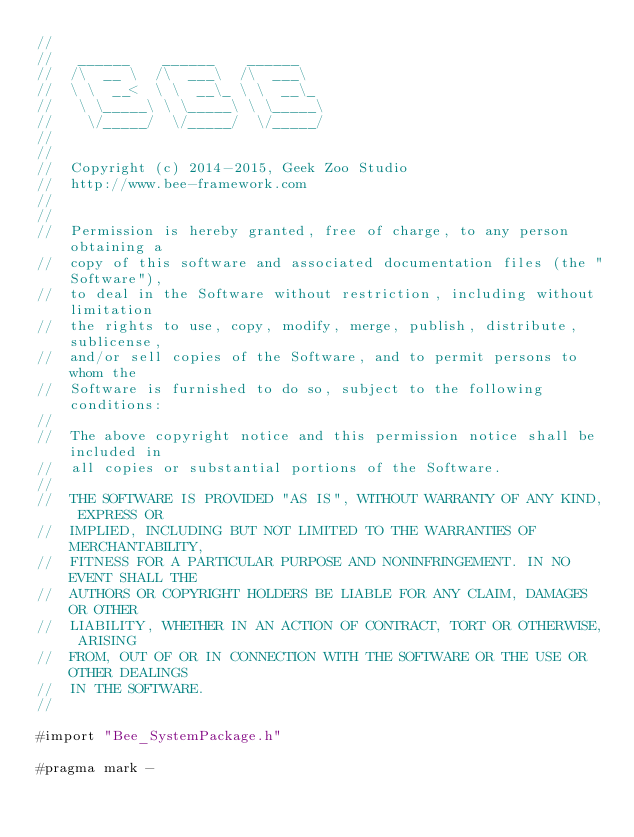<code> <loc_0><loc_0><loc_500><loc_500><_ObjectiveC_>//
//	 ______    ______    ______
//	/\  __ \  /\  ___\  /\  ___\
//	\ \  __<  \ \  __\_ \ \  __\_
//	 \ \_____\ \ \_____\ \ \_____\
//	  \/_____/  \/_____/  \/_____/
//
//
//	Copyright (c) 2014-2015, Geek Zoo Studio
//	http://www.bee-framework.com
//
//
//	Permission is hereby granted, free of charge, to any person obtaining a
//	copy of this software and associated documentation files (the "Software"),
//	to deal in the Software without restriction, including without limitation
//	the rights to use, copy, modify, merge, publish, distribute, sublicense,
//	and/or sell copies of the Software, and to permit persons to whom the
//	Software is furnished to do so, subject to the following conditions:
//
//	The above copyright notice and this permission notice shall be included in
//	all copies or substantial portions of the Software.
//
//	THE SOFTWARE IS PROVIDED "AS IS", WITHOUT WARRANTY OF ANY KIND, EXPRESS OR
//	IMPLIED, INCLUDING BUT NOT LIMITED TO THE WARRANTIES OF MERCHANTABILITY,
//	FITNESS FOR A PARTICULAR PURPOSE AND NONINFRINGEMENT. IN NO EVENT SHALL THE
//	AUTHORS OR COPYRIGHT HOLDERS BE LIABLE FOR ANY CLAIM, DAMAGES OR OTHER
//	LIABILITY, WHETHER IN AN ACTION OF CONTRACT, TORT OR OTHERWISE, ARISING
//	FROM, OUT OF OR IN CONNECTION WITH THE SOFTWARE OR THE USE OR OTHER DEALINGS
//	IN THE SOFTWARE.
//

#import "Bee_SystemPackage.h"

#pragma mark -
</code> 